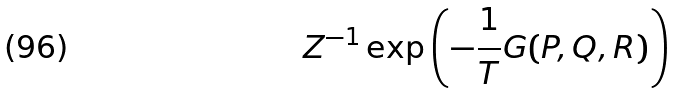Convert formula to latex. <formula><loc_0><loc_0><loc_500><loc_500>Z ^ { - 1 } \exp { \left ( - \frac { 1 } { T } G ( P , Q , R ) \right ) }</formula> 